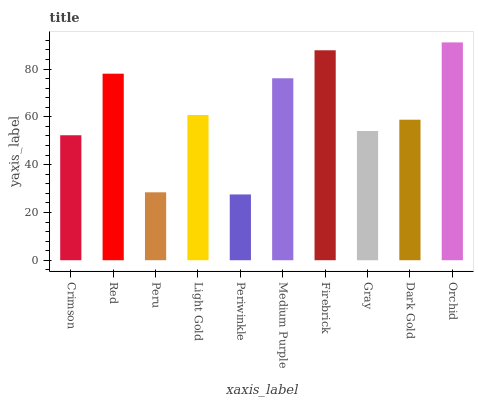Is Periwinkle the minimum?
Answer yes or no. Yes. Is Orchid the maximum?
Answer yes or no. Yes. Is Red the minimum?
Answer yes or no. No. Is Red the maximum?
Answer yes or no. No. Is Red greater than Crimson?
Answer yes or no. Yes. Is Crimson less than Red?
Answer yes or no. Yes. Is Crimson greater than Red?
Answer yes or no. No. Is Red less than Crimson?
Answer yes or no. No. Is Light Gold the high median?
Answer yes or no. Yes. Is Dark Gold the low median?
Answer yes or no. Yes. Is Peru the high median?
Answer yes or no. No. Is Crimson the low median?
Answer yes or no. No. 